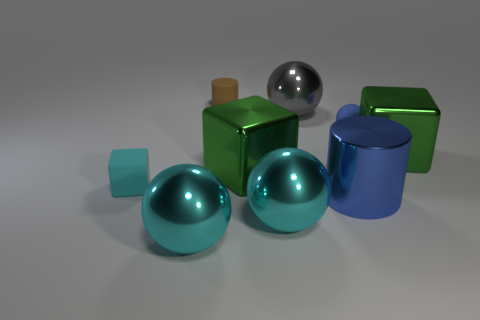Subtract all shiny blocks. How many blocks are left? 1 Subtract all purple spheres. How many green cubes are left? 2 Subtract 2 balls. How many balls are left? 2 Subtract all cyan blocks. How many blocks are left? 2 Subtract all cylinders. How many objects are left? 7 Subtract all yellow balls. Subtract all cyan blocks. How many balls are left? 4 Subtract all green rubber cylinders. Subtract all big cyan objects. How many objects are left? 7 Add 8 large gray shiny things. How many large gray shiny things are left? 9 Add 8 blue matte objects. How many blue matte objects exist? 9 Subtract 1 blue cylinders. How many objects are left? 8 